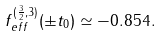Convert formula to latex. <formula><loc_0><loc_0><loc_500><loc_500>f _ { e f f } ^ { ( \frac { 3 } { 2 } , 3 ) } ( \pm t _ { 0 } ) \simeq - 0 . 8 5 4 .</formula> 